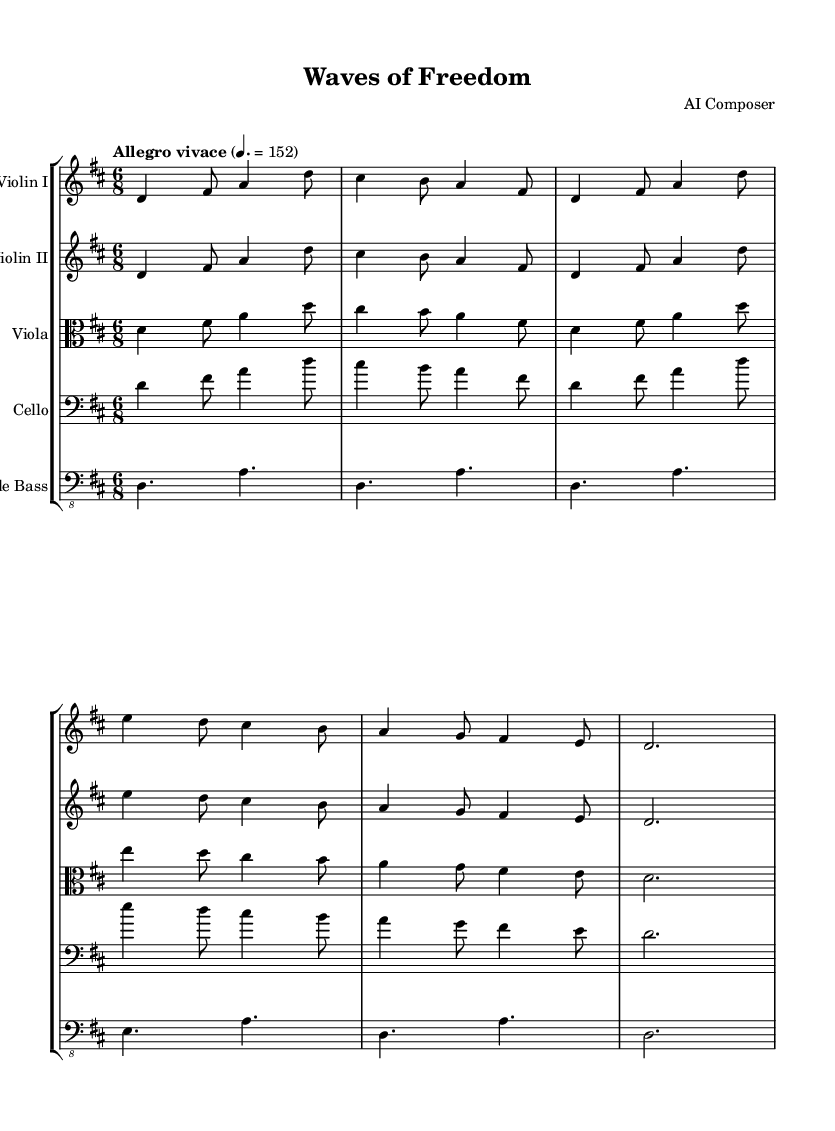What is the key signature of this music? The key signature appears at the beginning of the score, indicating D major, which has two sharps (F# and C#).
Answer: D major What is the time signature of this music? The time signature is located right after the key signature, displayed as a fraction; it shows 6 over 8, which means there are six eighth notes per measure.
Answer: 6/8 What is the tempo marking of this music? The tempo marking is generally found at the beginning of the score, written above the staff; it reads "Allegro vivace" with a metronome mark of 152, indicating a fast and lively pace.
Answer: Allegro vivace, 152 How many staves are in the score? The score displays multiple instrumental parts, each represented on its own staff; there are five staves total for Violin I, Violin II, Viola, Cello, and Double Bass.
Answer: 5 Which instrument has the lowest range in this orchestration? By identifying the clefs used, we can see that the Double Bass is written in the bass clef, which typically plays the lowest notes in an orchestral arrangement compared to the other instruments.
Answer: Double Bass What does the main theme represent in the context of nautical sports? The main theme is characterized by a lively and energetic rhythm, suggesting the freedom and excitement one feels while engaging in high-speed nautical activities, like jet skiing.
Answer: Freedom and excitement Which instrument plays the main theme first? Looking at the score, the Violin I part is the first to present the main theme, making it the featured instrument at the beginning of the piece.
Answer: Violin I 